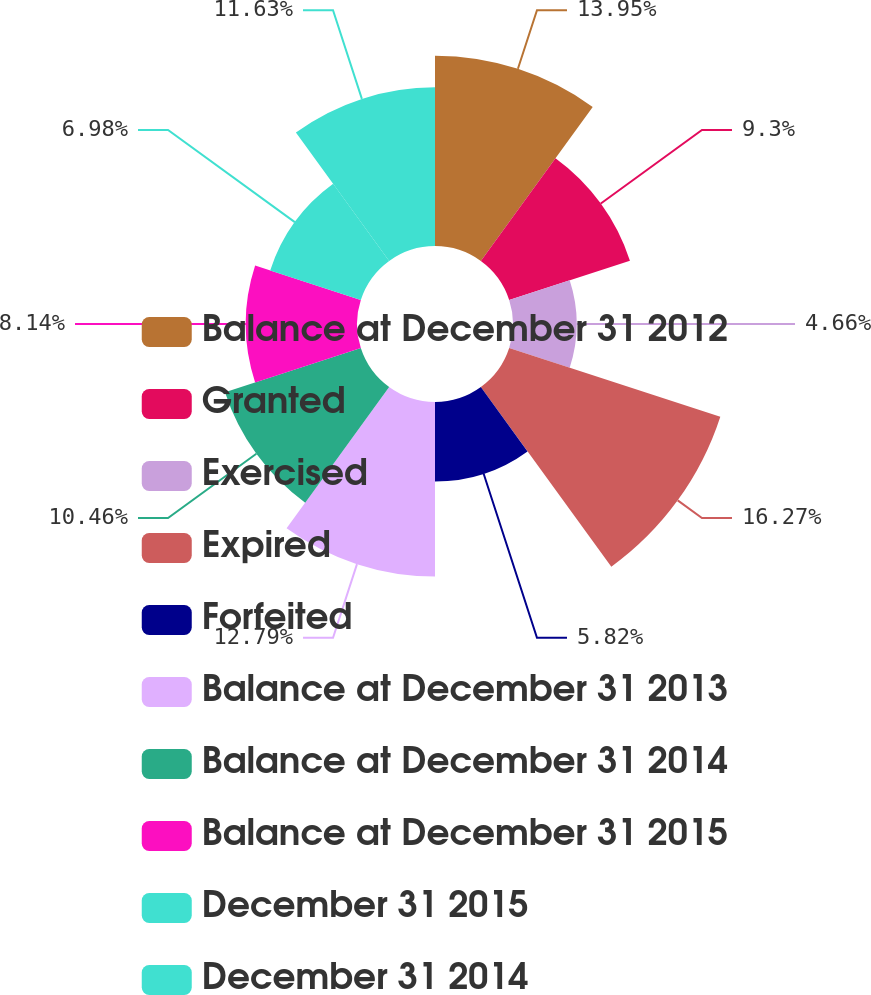Convert chart to OTSL. <chart><loc_0><loc_0><loc_500><loc_500><pie_chart><fcel>Balance at December 31 2012<fcel>Granted<fcel>Exercised<fcel>Expired<fcel>Forfeited<fcel>Balance at December 31 2013<fcel>Balance at December 31 2014<fcel>Balance at December 31 2015<fcel>December 31 2015<fcel>December 31 2014<nl><fcel>13.94%<fcel>9.3%<fcel>4.66%<fcel>16.26%<fcel>5.82%<fcel>12.78%<fcel>10.46%<fcel>8.14%<fcel>6.98%<fcel>11.62%<nl></chart> 